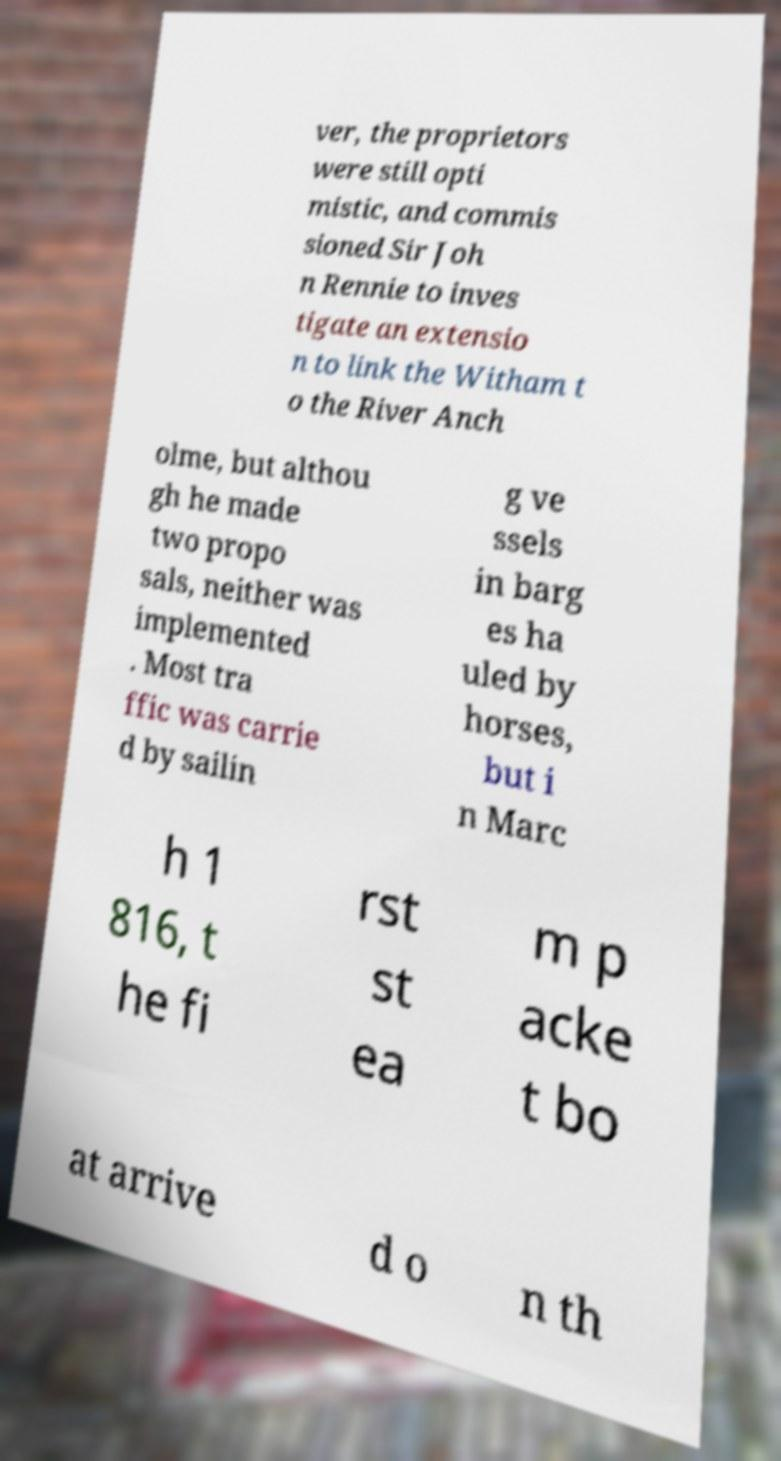Can you accurately transcribe the text from the provided image for me? ver, the proprietors were still opti mistic, and commis sioned Sir Joh n Rennie to inves tigate an extensio n to link the Witham t o the River Anch olme, but althou gh he made two propo sals, neither was implemented . Most tra ffic was carrie d by sailin g ve ssels in barg es ha uled by horses, but i n Marc h 1 816, t he fi rst st ea m p acke t bo at arrive d o n th 